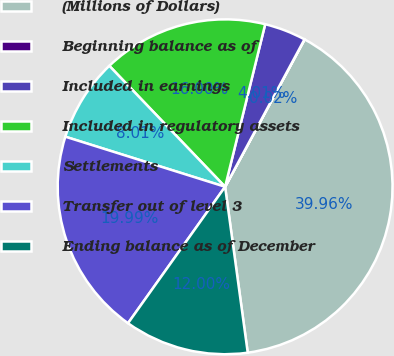Convert chart. <chart><loc_0><loc_0><loc_500><loc_500><pie_chart><fcel>(Millions of Dollars)<fcel>Beginning balance as of<fcel>Included in earnings<fcel>Included in regulatory assets<fcel>Settlements<fcel>Transfer out of level 3<fcel>Ending balance as of December<nl><fcel>39.96%<fcel>0.02%<fcel>4.01%<fcel>16.0%<fcel>8.01%<fcel>19.99%<fcel>12.0%<nl></chart> 